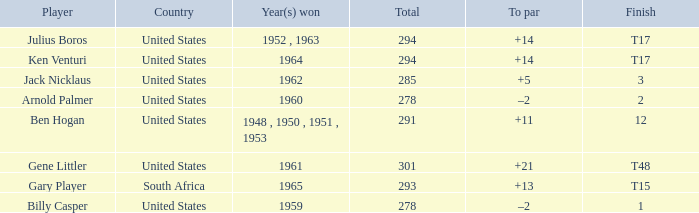What is Finish, when Country is "United States", and when To Par is "+21"? T48. 